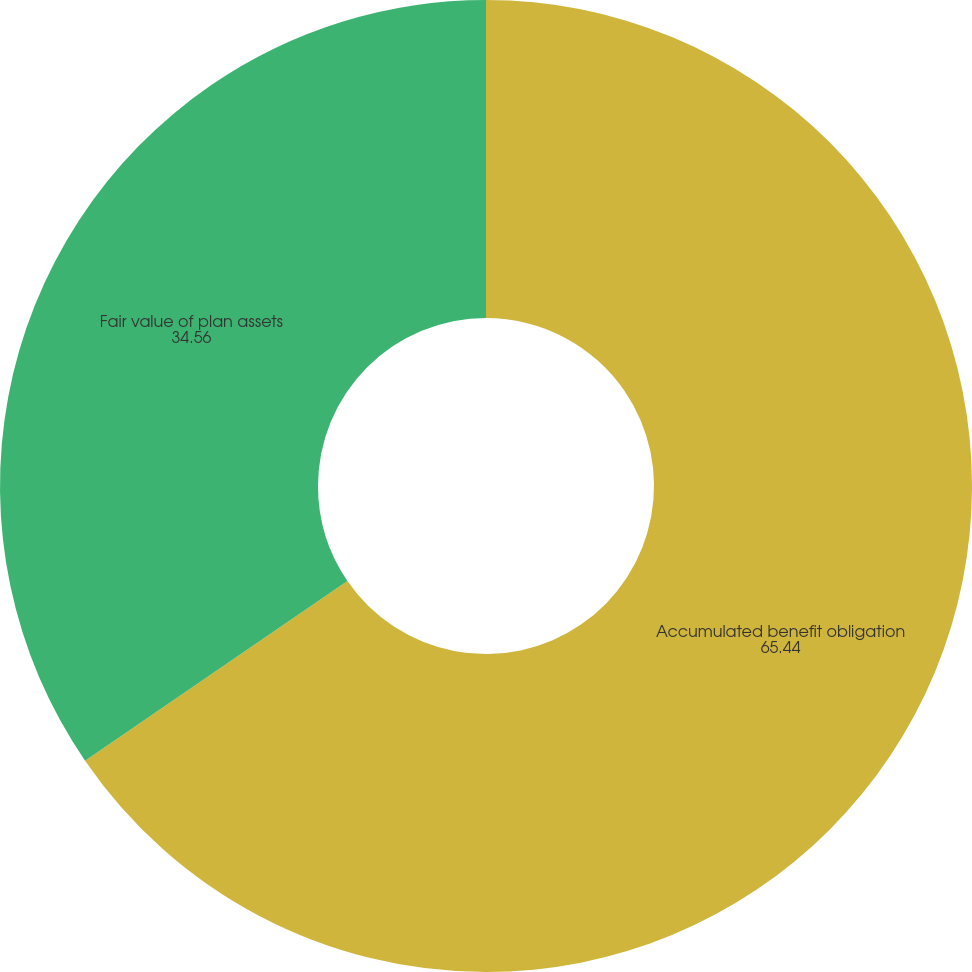Convert chart to OTSL. <chart><loc_0><loc_0><loc_500><loc_500><pie_chart><fcel>Accumulated benefit obligation<fcel>Fair value of plan assets<nl><fcel>65.44%<fcel>34.56%<nl></chart> 